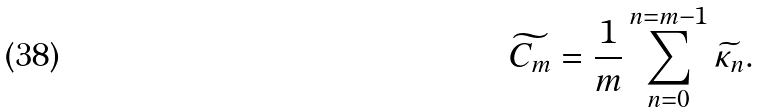Convert formula to latex. <formula><loc_0><loc_0><loc_500><loc_500>\widetilde { C _ { m } } = \frac { 1 } { m } \sum ^ { n = m - 1 } _ { n = 0 } \widetilde { \kappa _ { n } } .</formula> 